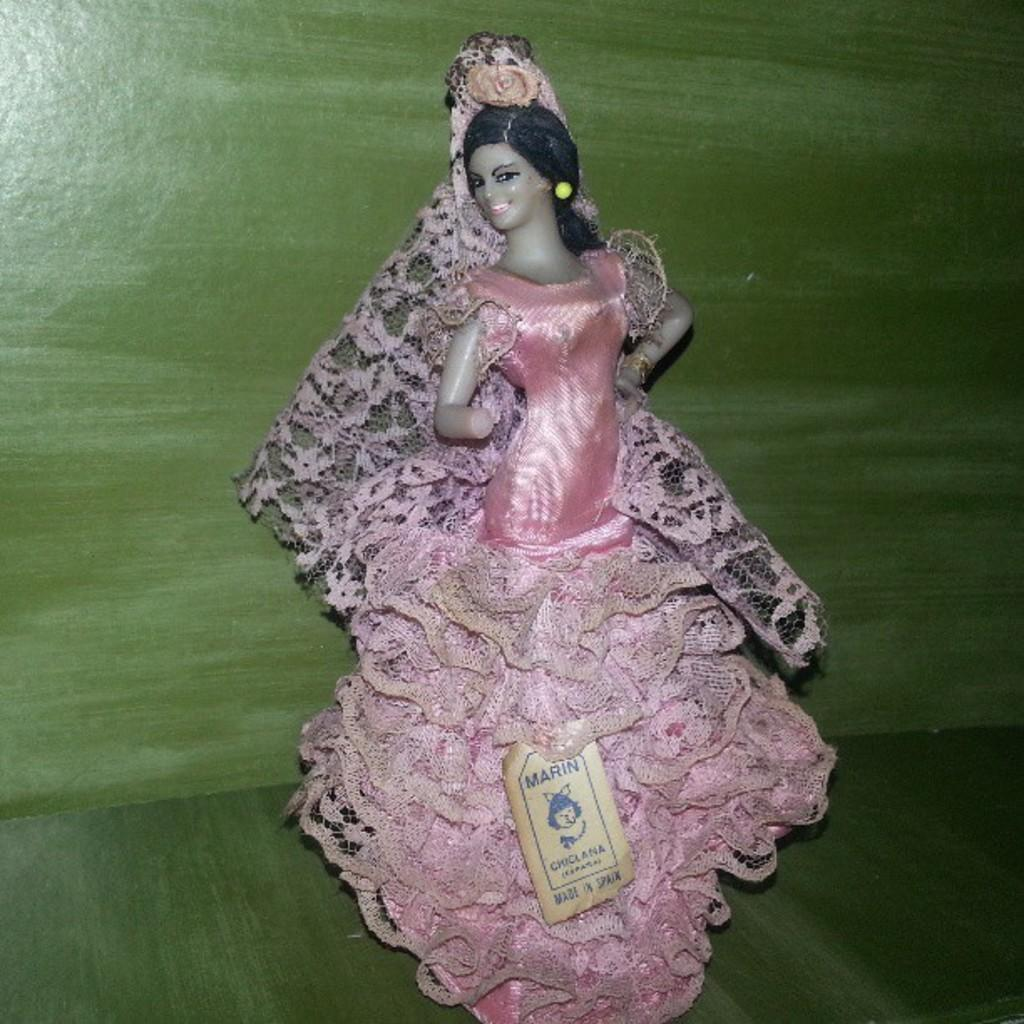What is the main subject of the image? There is a doll in the image. Can you describe the doll's appearance? The doll is of a girl child and is wearing a pink dress. What can be seen in the background of the image? There is a green wall in the background of the image. How does the beggar interact with the doll in the image? There is no beggar present in the image; it only features a doll. What type of wave can be seen in the image? There is no wave present in the image; it is a still image of a doll. 